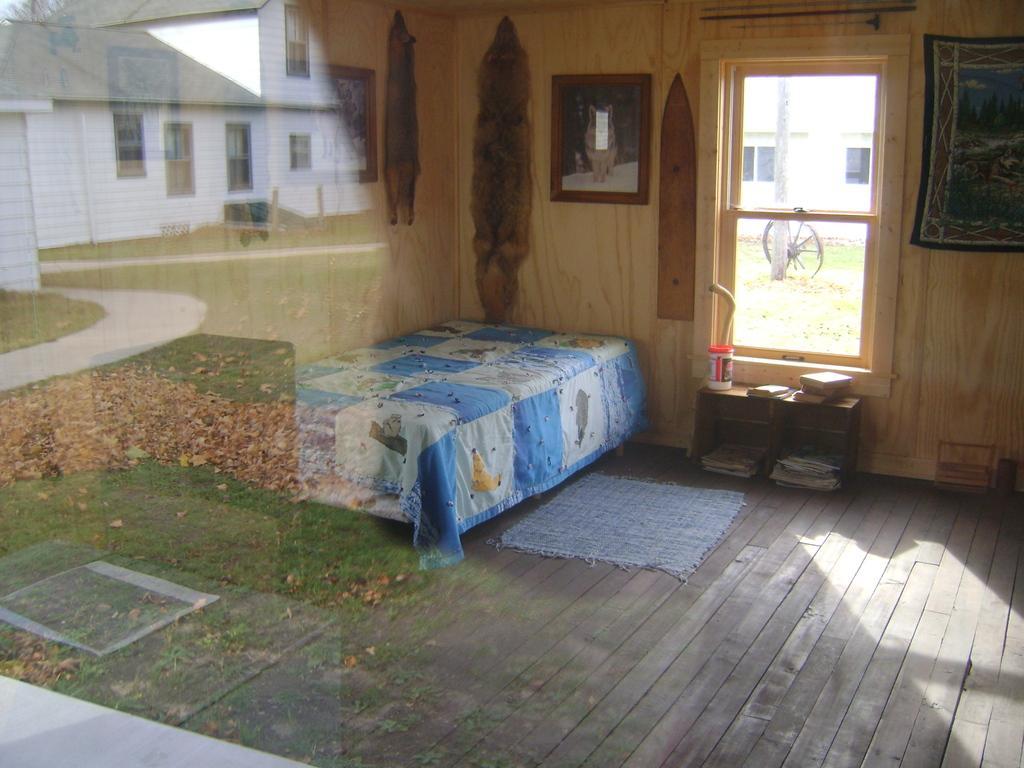Describe this image in one or two sentences. This is a picture of a bedroom. In the foreground there is a glass, in the glass we can see the reflection of dry leaves, grass and building. In the room there are frames, poster, bed, desk, books, window, mat and other objects. In the center of the picture there is a window, outside the window there are building, pole, wheel and grass. 